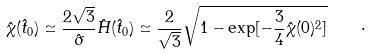Convert formula to latex. <formula><loc_0><loc_0><loc_500><loc_500>\hat { \chi } ( \hat { t } _ { 0 } ) \simeq \frac { 2 \sqrt { 3 } } { \hat { \sigma } } \hat { H } ( \hat { t } _ { 0 } ) \simeq \frac { 2 } { \sqrt { 3 } } \sqrt { 1 - \exp [ - \frac { 3 } { 4 } \hat { \chi } ( 0 ) ^ { 2 } ] } \quad \cdot</formula> 